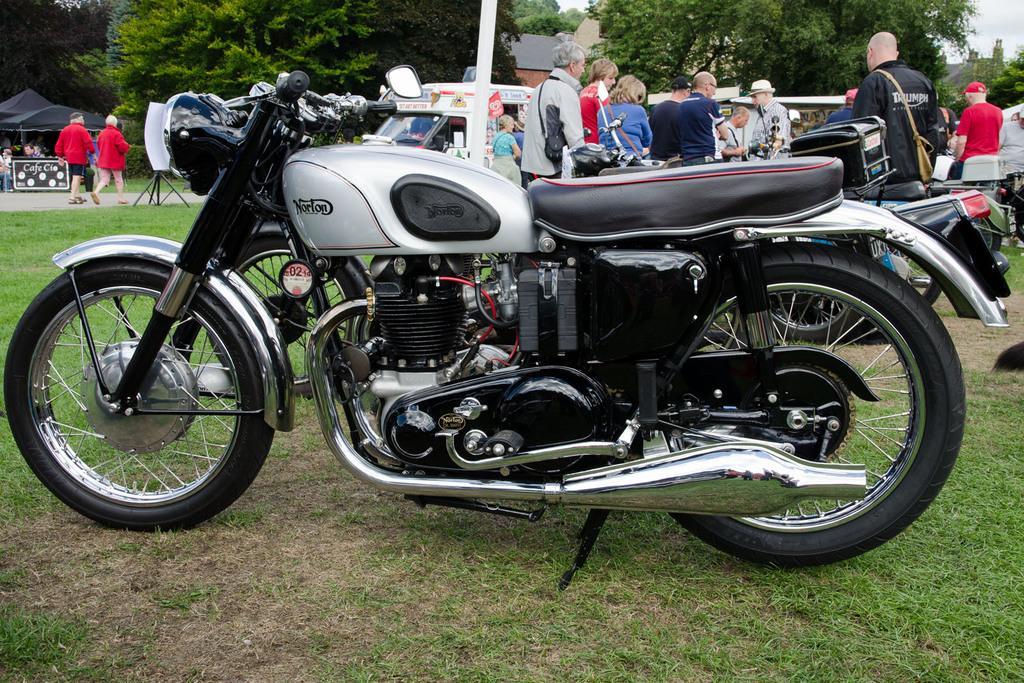Can you describe this image briefly? In the image there are few bikes on the grassland and behind there are many people standing and holding, there is a tent on the left side and few vehicles in the background, behind it there are trees. 